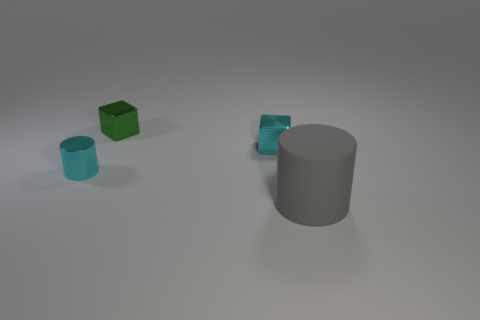There is a cyan object that is the same shape as the gray thing; what size is it?
Offer a terse response. Small. How many cylinders are both behind the matte object and on the right side of the tiny cyan shiny cylinder?
Keep it short and to the point. 0. Does the matte thing have the same shape as the small object on the right side of the tiny green thing?
Keep it short and to the point. No. Are there more tiny metal cylinders that are on the right side of the small green metal object than tiny things?
Provide a succinct answer. No. Are there fewer large gray matte cylinders that are on the left side of the small cyan cylinder than small shiny blocks?
Your answer should be compact. Yes. What number of metallic cubes are the same color as the rubber thing?
Give a very brief answer. 0. The object that is to the right of the small green block and behind the big gray thing is made of what material?
Keep it short and to the point. Metal. There is a tiny metallic object that is to the right of the green thing; does it have the same color as the cylinder that is behind the big cylinder?
Ensure brevity in your answer.  Yes. What number of cyan things are metal cylinders or large cylinders?
Make the answer very short. 1. Are there fewer big objects that are behind the large gray cylinder than small metal things that are in front of the tiny cyan shiny cube?
Offer a terse response. Yes. 